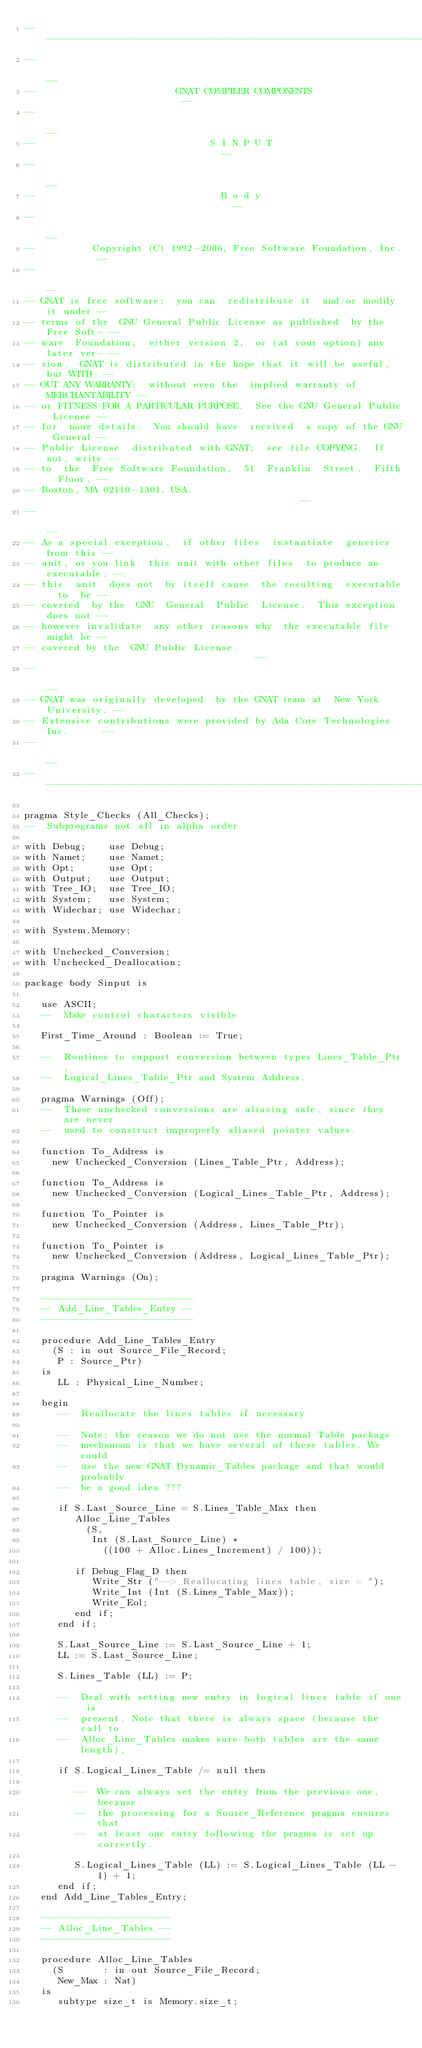Convert code to text. <code><loc_0><loc_0><loc_500><loc_500><_Ada_>------------------------------------------------------------------------------
--                                                                          --
--                         GNAT COMPILER COMPONENTS                         --
--                                                                          --
--                               S I N P U T                                --
--                                                                          --
--                                 B o d y                                  --
--                                                                          --
--          Copyright (C) 1992-2006, Free Software Foundation, Inc.         --
--                                                                          --
-- GNAT is free software;  you can  redistribute it  and/or modify it under --
-- terms of the  GNU General Public License as published  by the Free Soft- --
-- ware  Foundation;  either version 2,  or (at your option) any later ver- --
-- sion.  GNAT is distributed in the hope that it will be useful, but WITH- --
-- OUT ANY WARRANTY;  without even the  implied warranty of MERCHANTABILITY --
-- or FITNESS FOR A PARTICULAR PURPOSE.  See the GNU General Public License --
-- for  more details.  You should have  received  a copy of the GNU General --
-- Public License  distributed with GNAT;  see file COPYING.  If not, write --
-- to  the  Free Software Foundation,  51  Franklin  Street,  Fifth  Floor, --
-- Boston, MA 02110-1301, USA.                                              --
--                                                                          --
-- As a special exception,  if other files  instantiate  generics from this --
-- unit, or you link  this unit with other files  to produce an executable, --
-- this  unit  does not  by itself cause  the resulting  executable  to  be --
-- covered  by the  GNU  General  Public  License.  This exception does not --
-- however invalidate  any other reasons why  the executable file  might be --
-- covered by the  GNU Public License.                                      --
--                                                                          --
-- GNAT was originally developed  by the GNAT team at  New York University. --
-- Extensive contributions were provided by Ada Core Technologies Inc.      --
--                                                                          --
------------------------------------------------------------------------------

pragma Style_Checks (All_Checks);
--  Subprograms not all in alpha order

with Debug;    use Debug;
with Namet;    use Namet;
with Opt;      use Opt;
with Output;   use Output;
with Tree_IO;  use Tree_IO;
with System;   use System;
with Widechar; use Widechar;

with System.Memory;

with Unchecked_Conversion;
with Unchecked_Deallocation;

package body Sinput is

   use ASCII;
   --  Make control characters visible

   First_Time_Around : Boolean := True;

   --  Routines to support conversion between types Lines_Table_Ptr,
   --  Logical_Lines_Table_Ptr and System.Address.

   pragma Warnings (Off);
   --  These unchecked conversions are aliasing safe, since they are never
   --  used to construct improperly aliased pointer values.

   function To_Address is
     new Unchecked_Conversion (Lines_Table_Ptr, Address);

   function To_Address is
     new Unchecked_Conversion (Logical_Lines_Table_Ptr, Address);

   function To_Pointer is
     new Unchecked_Conversion (Address, Lines_Table_Ptr);

   function To_Pointer is
     new Unchecked_Conversion (Address, Logical_Lines_Table_Ptr);

   pragma Warnings (On);

   ---------------------------
   -- Add_Line_Tables_Entry --
   ---------------------------

   procedure Add_Line_Tables_Entry
     (S : in out Source_File_Record;
      P : Source_Ptr)
   is
      LL : Physical_Line_Number;

   begin
      --  Reallocate the lines tables if necessary

      --  Note: the reason we do not use the normal Table package
      --  mechanism is that we have several of these tables. We could
      --  use the new GNAT.Dynamic_Tables package and that would probably
      --  be a good idea ???

      if S.Last_Source_Line = S.Lines_Table_Max then
         Alloc_Line_Tables
           (S,
            Int (S.Last_Source_Line) *
              ((100 + Alloc.Lines_Increment) / 100));

         if Debug_Flag_D then
            Write_Str ("--> Reallocating lines table, size = ");
            Write_Int (Int (S.Lines_Table_Max));
            Write_Eol;
         end if;
      end if;

      S.Last_Source_Line := S.Last_Source_Line + 1;
      LL := S.Last_Source_Line;

      S.Lines_Table (LL) := P;

      --  Deal with setting new entry in logical lines table if one is
      --  present. Note that there is always space (because the call to
      --  Alloc_Line_Tables makes sure both tables are the same length),

      if S.Logical_Lines_Table /= null then

         --  We can always set the entry from the previous one, because
         --  the processing for a Source_Reference pragma ensures that
         --  at least one entry following the pragma is set up correctly.

         S.Logical_Lines_Table (LL) := S.Logical_Lines_Table (LL - 1) + 1;
      end if;
   end Add_Line_Tables_Entry;

   -----------------------
   -- Alloc_Line_Tables --
   -----------------------

   procedure Alloc_Line_Tables
     (S       : in out Source_File_Record;
      New_Max : Nat)
   is
      subtype size_t is Memory.size_t;
</code> 